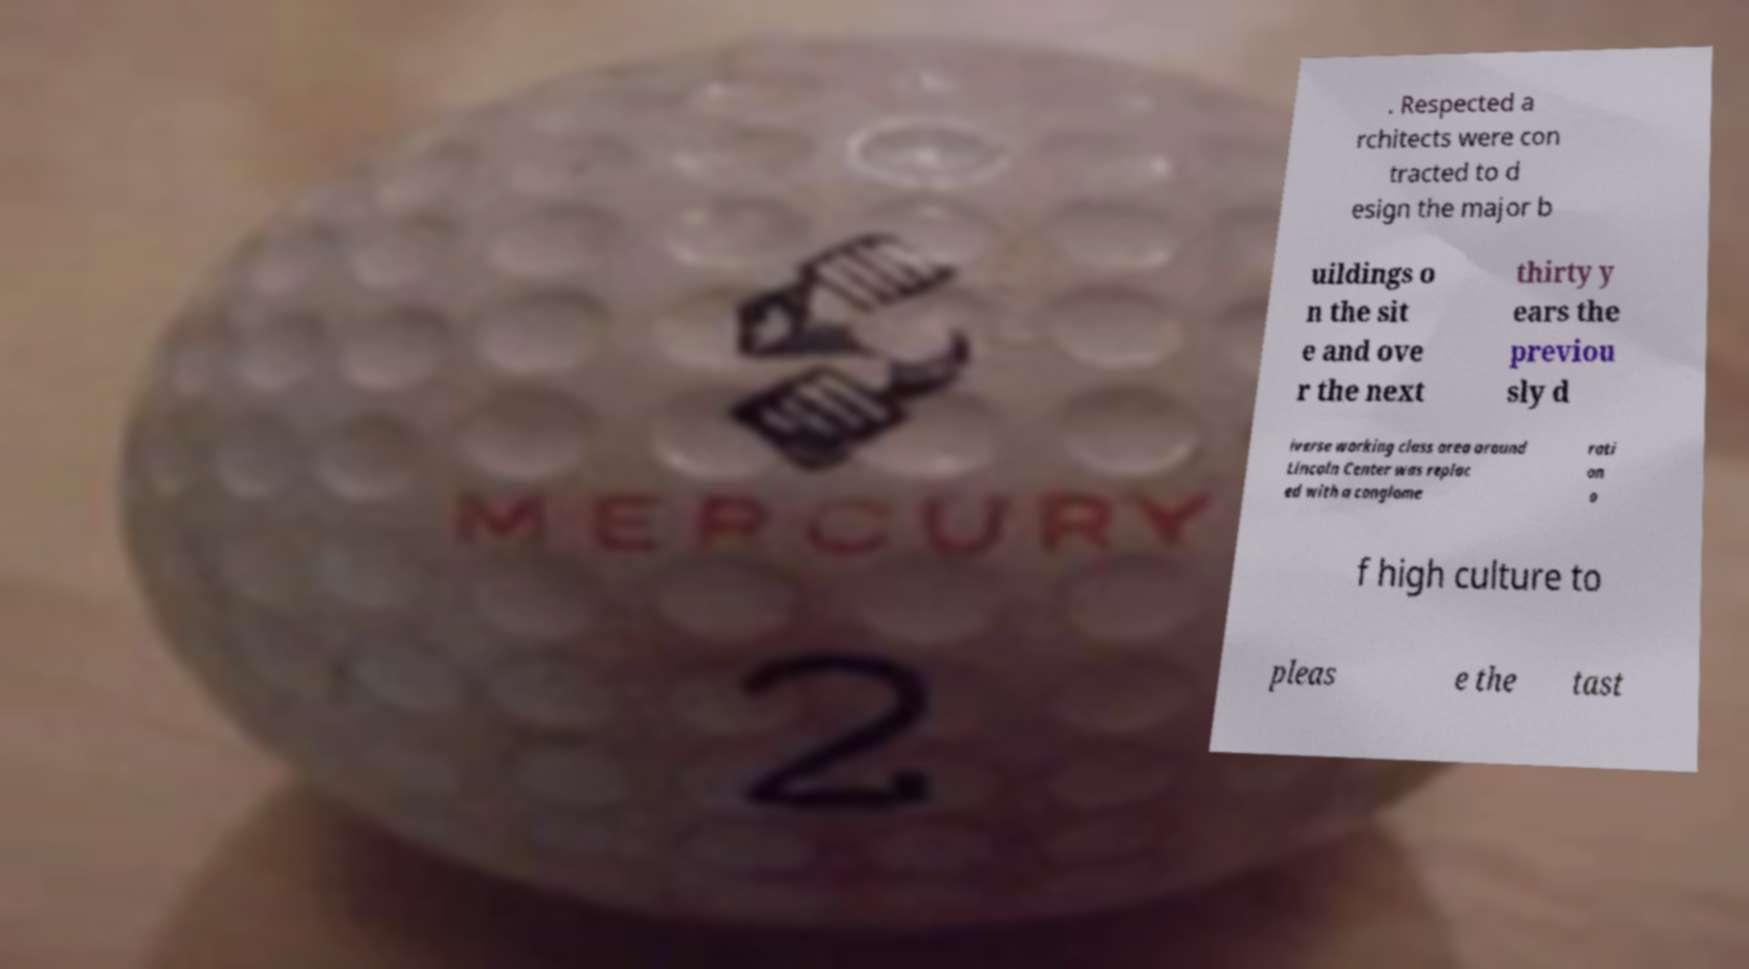For documentation purposes, I need the text within this image transcribed. Could you provide that? . Respected a rchitects were con tracted to d esign the major b uildings o n the sit e and ove r the next thirty y ears the previou sly d iverse working class area around Lincoln Center was replac ed with a conglome rati on o f high culture to pleas e the tast 